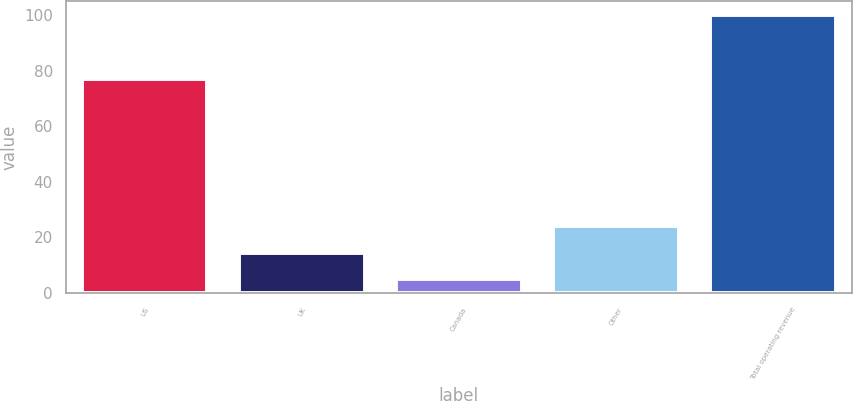<chart> <loc_0><loc_0><loc_500><loc_500><bar_chart><fcel>US<fcel>UK<fcel>Canada<fcel>Other<fcel>Total operating revenue<nl><fcel>77<fcel>14.5<fcel>5<fcel>24<fcel>100<nl></chart> 